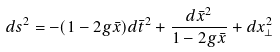Convert formula to latex. <formula><loc_0><loc_0><loc_500><loc_500>d s ^ { 2 } = - ( 1 - 2 g \bar { x } ) d \bar { t } ^ { 2 } + \frac { d \bar { x } ^ { 2 } } { 1 - 2 g \bar { x } } + d x _ { \bot } ^ { 2 }</formula> 